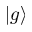<formula> <loc_0><loc_0><loc_500><loc_500>| g \rangle</formula> 